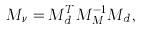<formula> <loc_0><loc_0><loc_500><loc_500>M _ { \nu } = M _ { d } ^ { T } M _ { M } ^ { - 1 } M _ { d } ,</formula> 